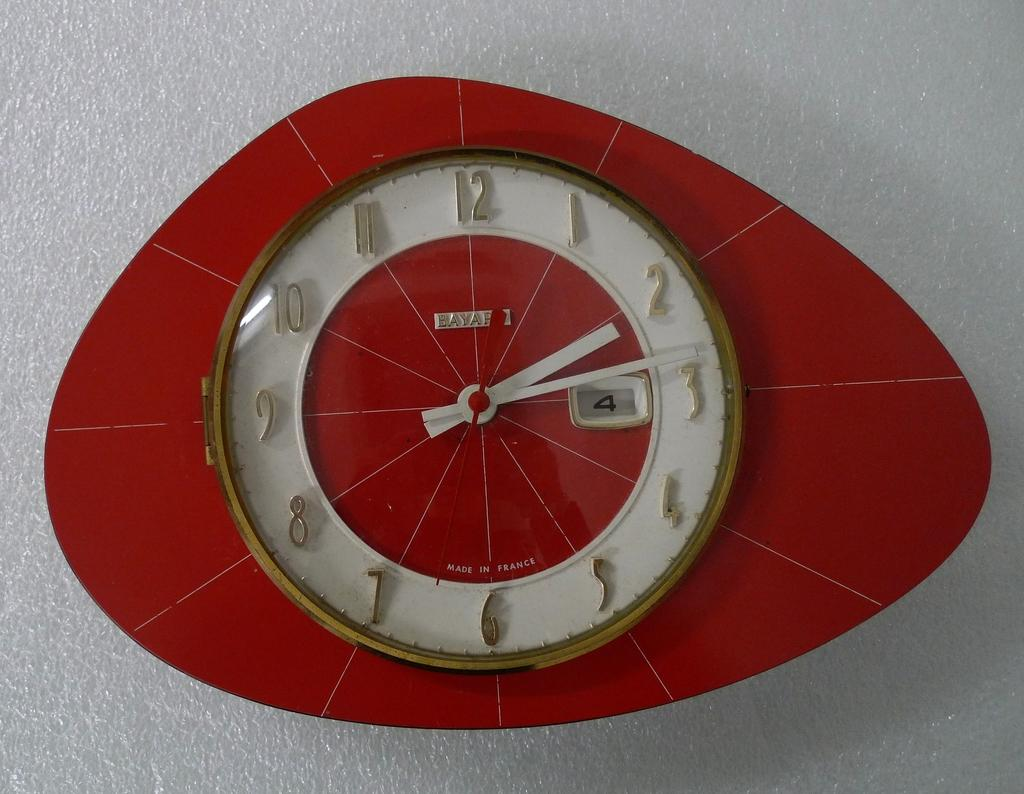<image>
Summarize the visual content of the image. A red Bayar clock showing the time 2:14. 